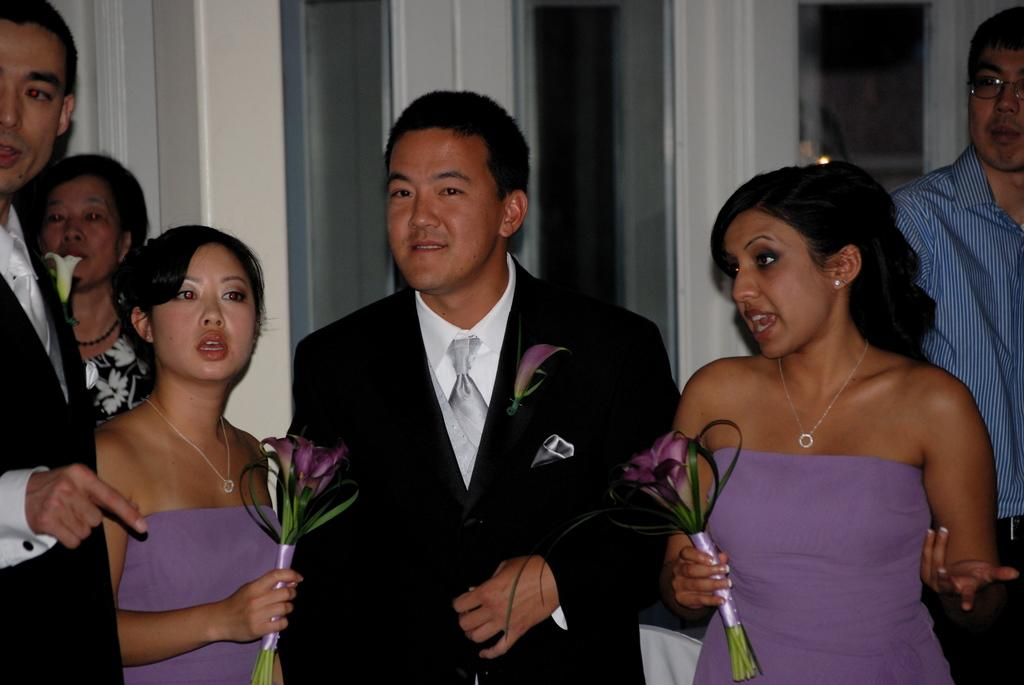How many people are in the image? There is a group of people in the image. What are some of the people doing in the image? Some of the people are standing, and some of them are talking. What can be seen behind the people in the image? There is a door visible behind the people. What type of design is featured on the cream that the people are holding in the image? There is no cream present in the image, and therefore no design can be observed. 